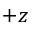<formula> <loc_0><loc_0><loc_500><loc_500>+ z</formula> 